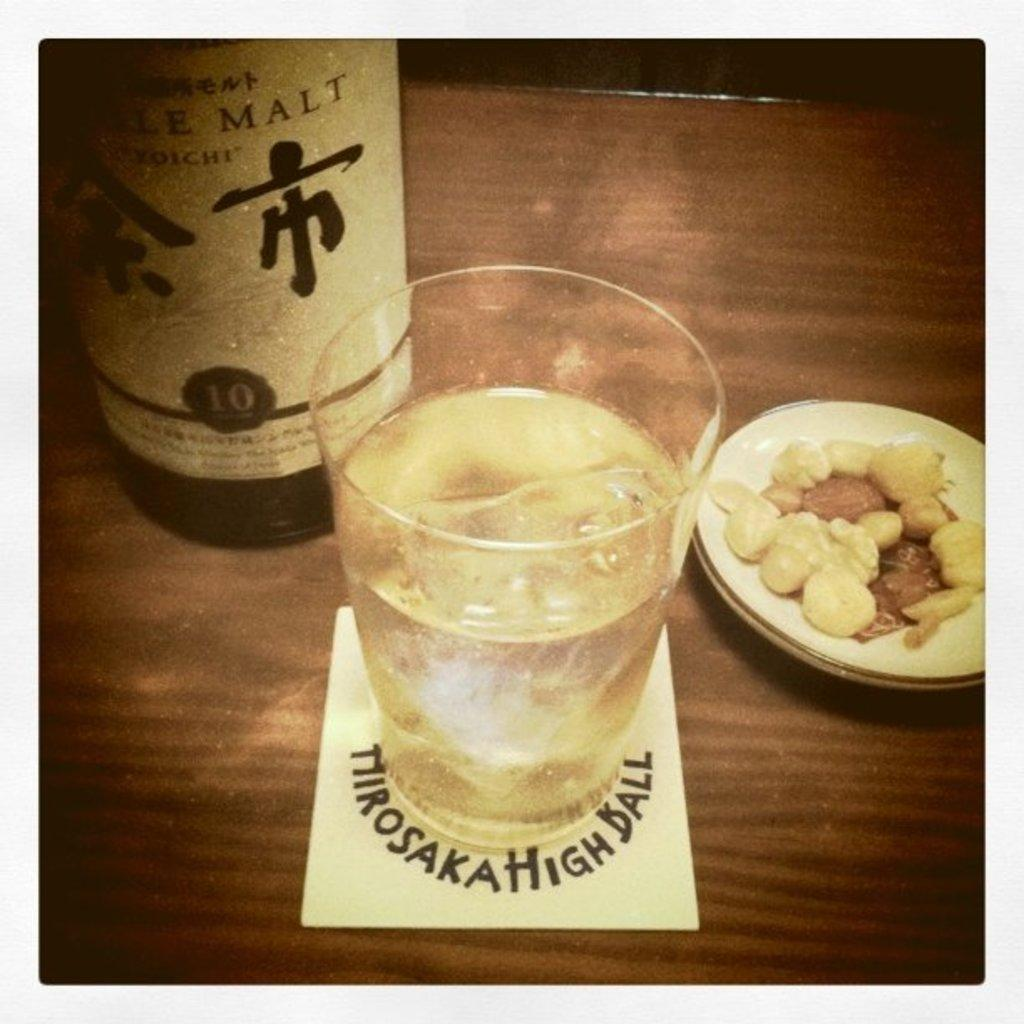<image>
Write a terse but informative summary of the picture. the word tirosaka that is on a napkin 